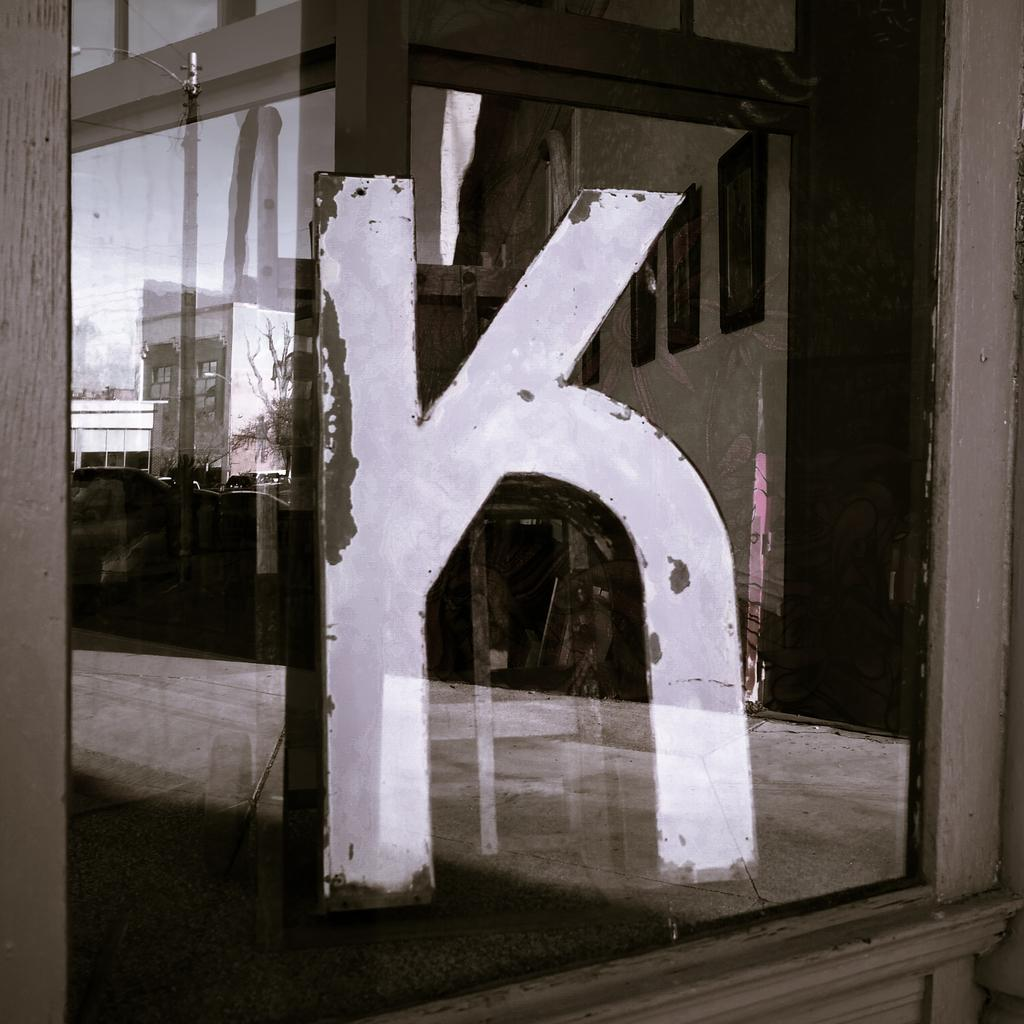What type of structure is present in the image? There is a glass window in the image. What is written on the glass window? The letter "k" is written on the window. What can be seen through the window? Buildings, trees, and a street light are visible through the window. What type of engine can be seen in the image? There is no engine present in the image; it features a glass window with the letter "k" written on it and views of buildings, trees, and a street light through the window. 